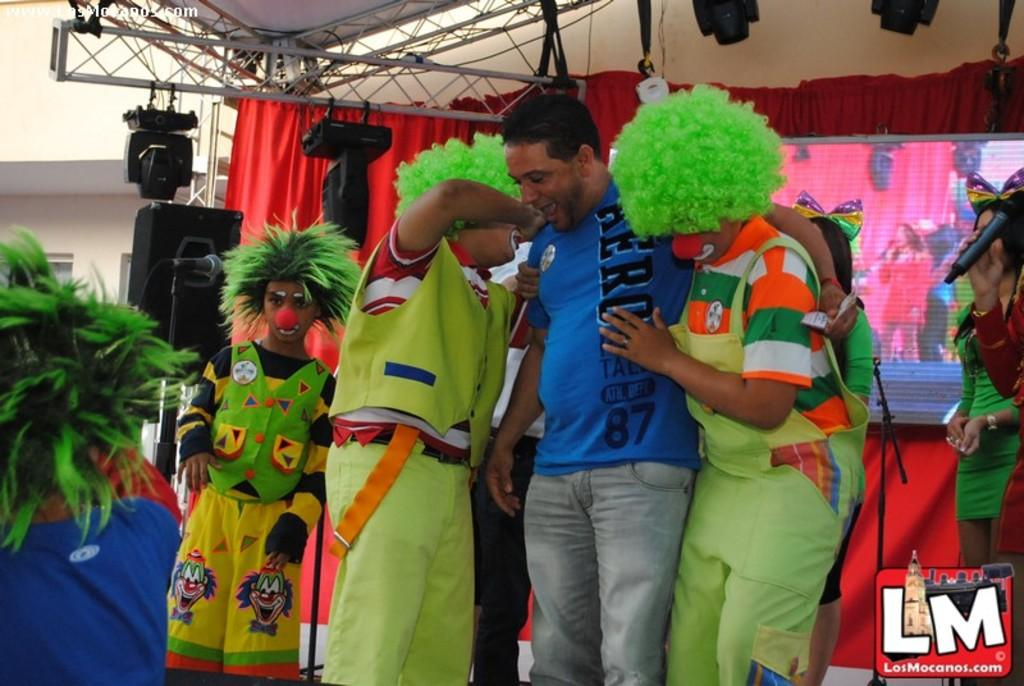What is the man in the image wearing? The man is wearing a blue t-shirt. How many other persons are standing beside the man? There are two other persons standing beside the man. Can you describe the appearance of one of the persons standing beside the man? One of the persons has green hair. What is the other person standing beside the man wearing? The other person is wearing a green dress. What can be seen in the background of the image? There is a stage visible in the background of the image. What type of balloon is being used as a mode of transportation in the image? There is no balloon present in the image, and therefore no mode of transportation involving a balloon can be observed. 